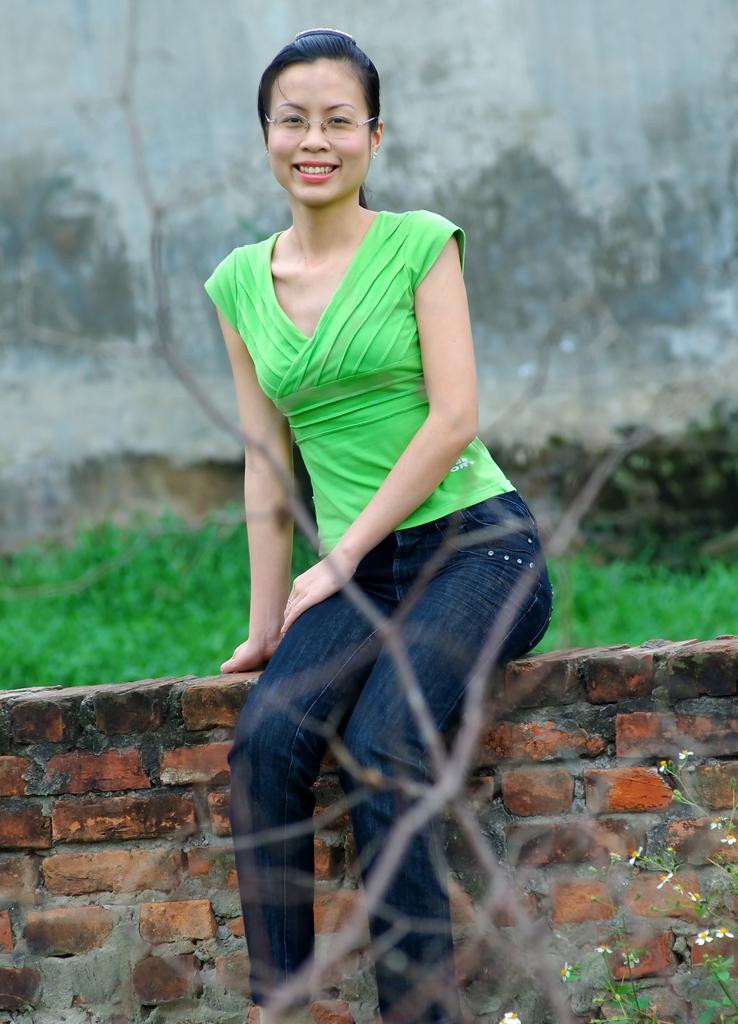How would you summarize this image in a sentence or two? In this picture we can see a woman in the green top is smiling and sitting on a brick wall. Behind the women there are plants and a wall. 